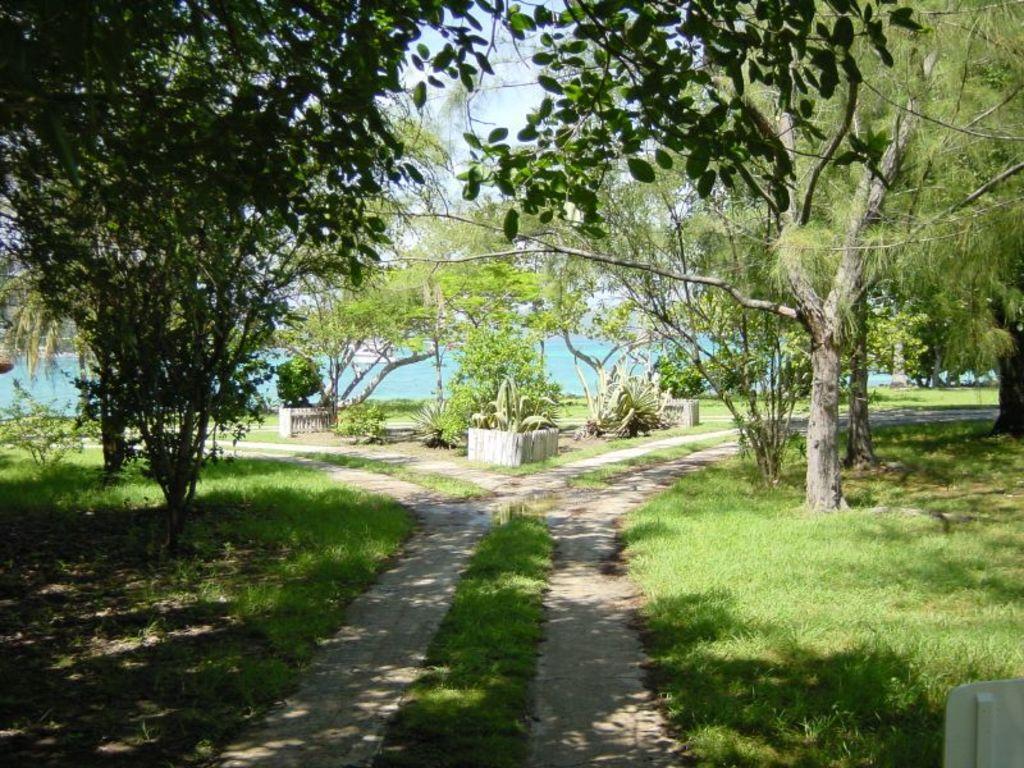Describe this image in one or two sentences. In the center of the image there are paths. At the bottom of the image there is grass on the surface. At the center of the image there are water and plants. In the background of the image there are trees and sky. 